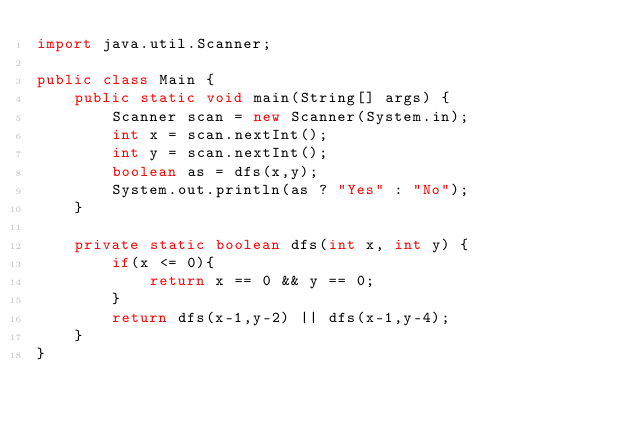<code> <loc_0><loc_0><loc_500><loc_500><_Java_>import java.util.Scanner;

public class Main {
    public static void main(String[] args) {
        Scanner scan = new Scanner(System.in);
        int x = scan.nextInt();
        int y = scan.nextInt();
        boolean as = dfs(x,y);
        System.out.println(as ? "Yes" : "No");
    }

    private static boolean dfs(int x, int y) {
        if(x <= 0){
            return x == 0 && y == 0;
        }
        return dfs(x-1,y-2) || dfs(x-1,y-4);
    }
}</code> 